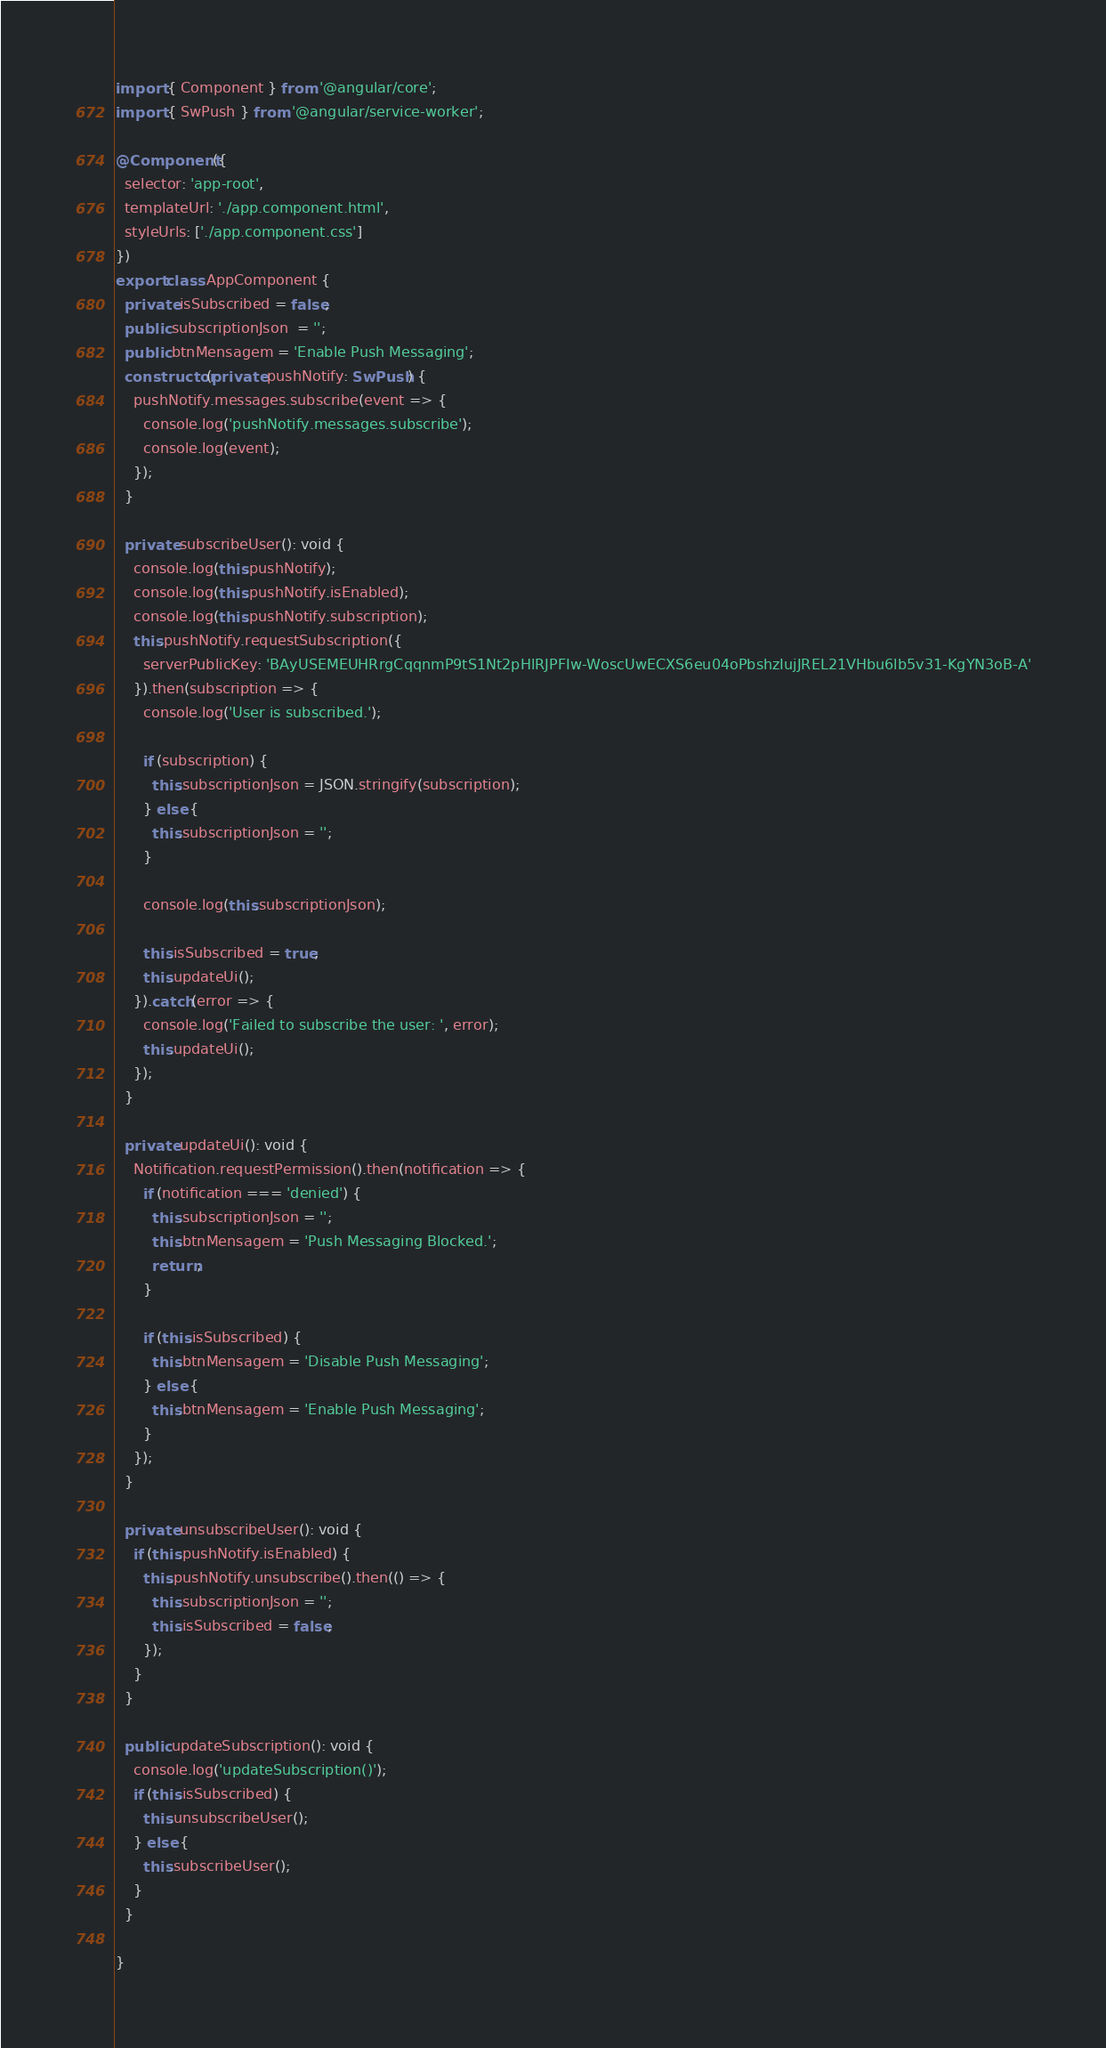Convert code to text. <code><loc_0><loc_0><loc_500><loc_500><_TypeScript_>import { Component } from '@angular/core';
import { SwPush } from '@angular/service-worker';

@Component({
  selector: 'app-root',
  templateUrl: './app.component.html',
  styleUrls: ['./app.component.css']
})
export class AppComponent {
  private isSubscribed = false;
  public subscriptionJson  = '';
  public btnMensagem = 'Enable Push Messaging';
  constructor(private pushNotify: SwPush) {
    pushNotify.messages.subscribe(event => {
      console.log('pushNotify.messages.subscribe');
      console.log(event);
    });
  }

  private subscribeUser(): void {
    console.log(this.pushNotify);
    console.log(this.pushNotify.isEnabled);
    console.log(this.pushNotify.subscription);
    this.pushNotify.requestSubscription({
      serverPublicKey: 'BAyUSEMEUHRrgCqqnmP9tS1Nt2pHlRJPFIw-WoscUwECXS6eu04oPbshzIujJREL21VHbu6lb5v31-KgYN3oB-A'
    }).then(subscription => {
      console.log('User is subscribed.');

      if (subscription) {
        this.subscriptionJson = JSON.stringify(subscription);
      } else {
        this.subscriptionJson = '';
      }

      console.log(this.subscriptionJson);

      this.isSubscribed = true;
      this.updateUi();
    }).catch(error => {
      console.log('Failed to subscribe the user: ', error);
      this.updateUi();
    });
  }

  private updateUi(): void {
    Notification.requestPermission().then(notification => {
      if (notification === 'denied') {
        this.subscriptionJson = '';
        this.btnMensagem = 'Push Messaging Blocked.';
        return;
      }

      if (this.isSubscribed) {
        this.btnMensagem = 'Disable Push Messaging';
      } else {
        this.btnMensagem = 'Enable Push Messaging';
      }
    });
  }

  private unsubscribeUser(): void {
    if (this.pushNotify.isEnabled) {
      this.pushNotify.unsubscribe().then(() => {
        this.subscriptionJson = '';
        this.isSubscribed = false;
      });
    }
  }

  public updateSubscription(): void {
    console.log('updateSubscription()');
    if (this.isSubscribed) {
      this.unsubscribeUser();
    } else {
      this.subscribeUser();
    }
  }

}
</code> 